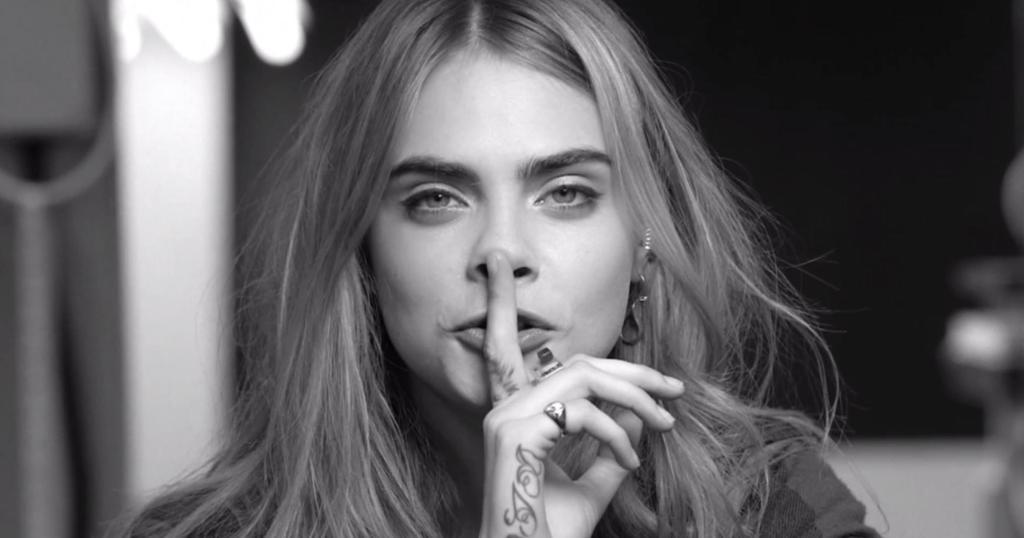What is the color scheme of the image? The image is black and white. Who is the main subject in the image? There is a girl in the middle of the image. What is the girl doing in the image? The girl has her finger on her mouth. Can you describe the background of the image? The background of the image is blurred. How many cars can be seen through the window in the image? There is no window or cars present in the image. What type of store is visible in the background of the image? There is no store visible in the image, as the background is blurred. 